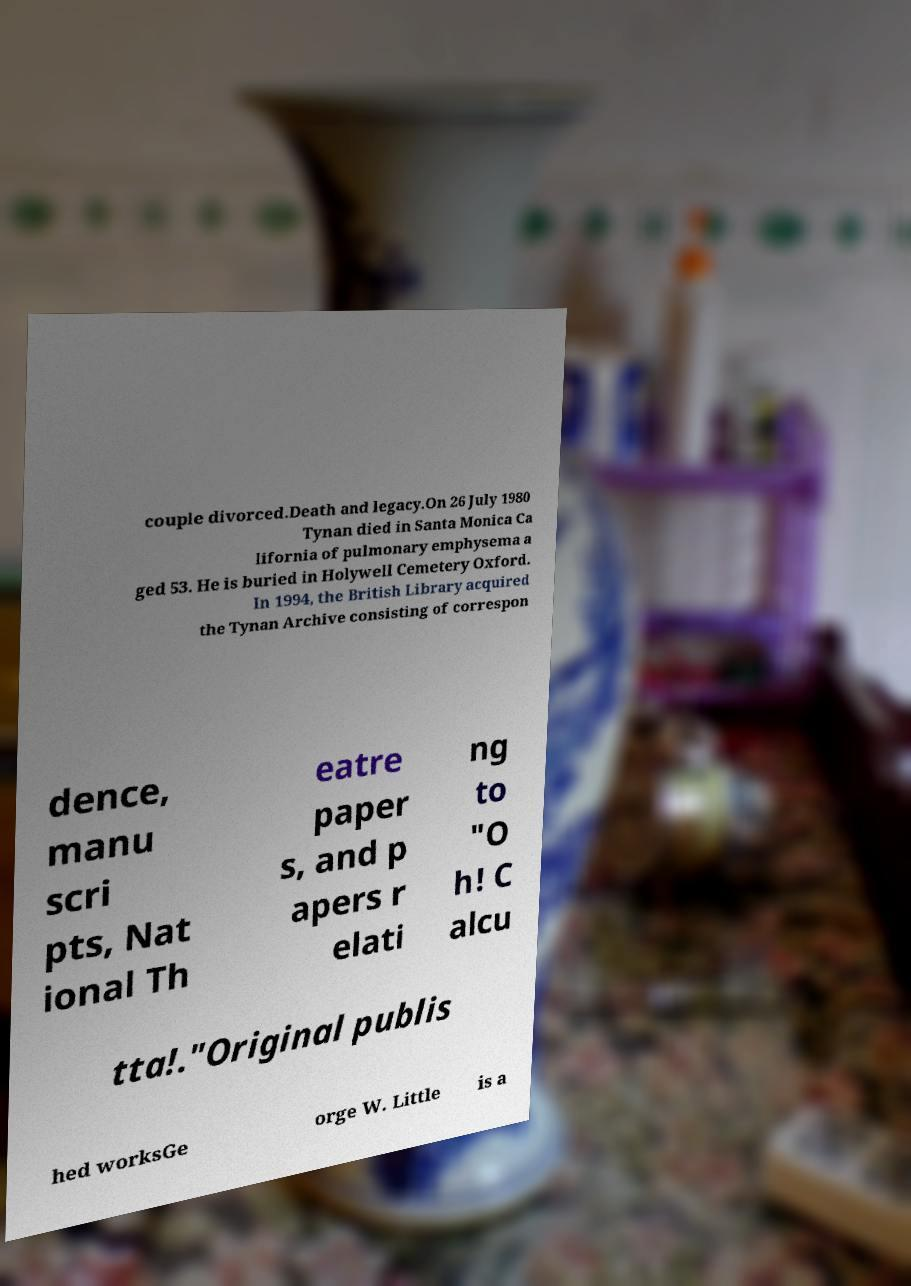There's text embedded in this image that I need extracted. Can you transcribe it verbatim? couple divorced.Death and legacy.On 26 July 1980 Tynan died in Santa Monica Ca lifornia of pulmonary emphysema a ged 53. He is buried in Holywell Cemetery Oxford. In 1994, the British Library acquired the Tynan Archive consisting of correspon dence, manu scri pts, Nat ional Th eatre paper s, and p apers r elati ng to "O h! C alcu tta!."Original publis hed worksGe orge W. Little is a 